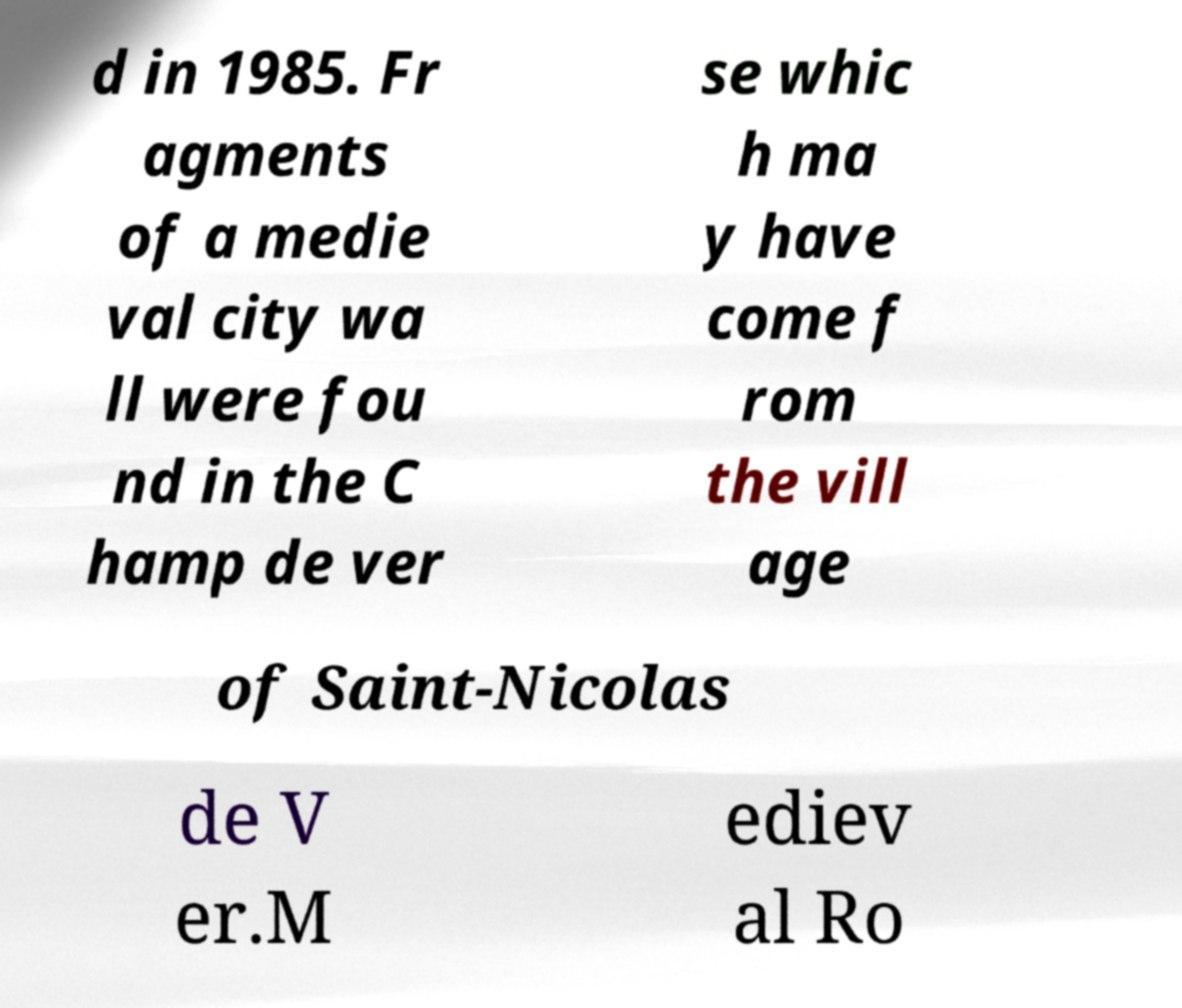Can you accurately transcribe the text from the provided image for me? d in 1985. Fr agments of a medie val city wa ll were fou nd in the C hamp de ver se whic h ma y have come f rom the vill age of Saint-Nicolas de V er.M ediev al Ro 